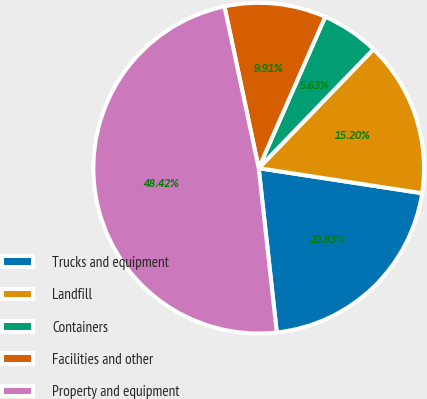Convert chart. <chart><loc_0><loc_0><loc_500><loc_500><pie_chart><fcel>Trucks and equipment<fcel>Landfill<fcel>Containers<fcel>Facilities and other<fcel>Property and equipment<nl><fcel>20.83%<fcel>15.2%<fcel>5.63%<fcel>9.91%<fcel>48.42%<nl></chart> 